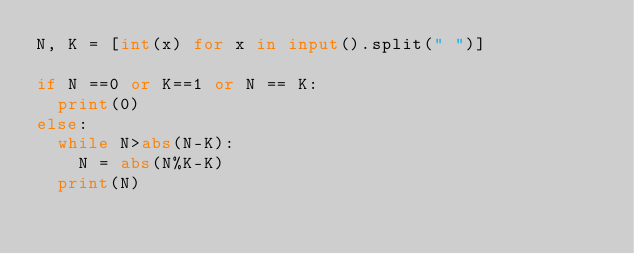<code> <loc_0><loc_0><loc_500><loc_500><_Python_>N, K = [int(x) for x in input().split(" ")]

if N ==0 or K==1 or N == K:
  print(0)
else:
  while N>abs(N-K):
    N = abs(N%K-K)
  print(N)
</code> 